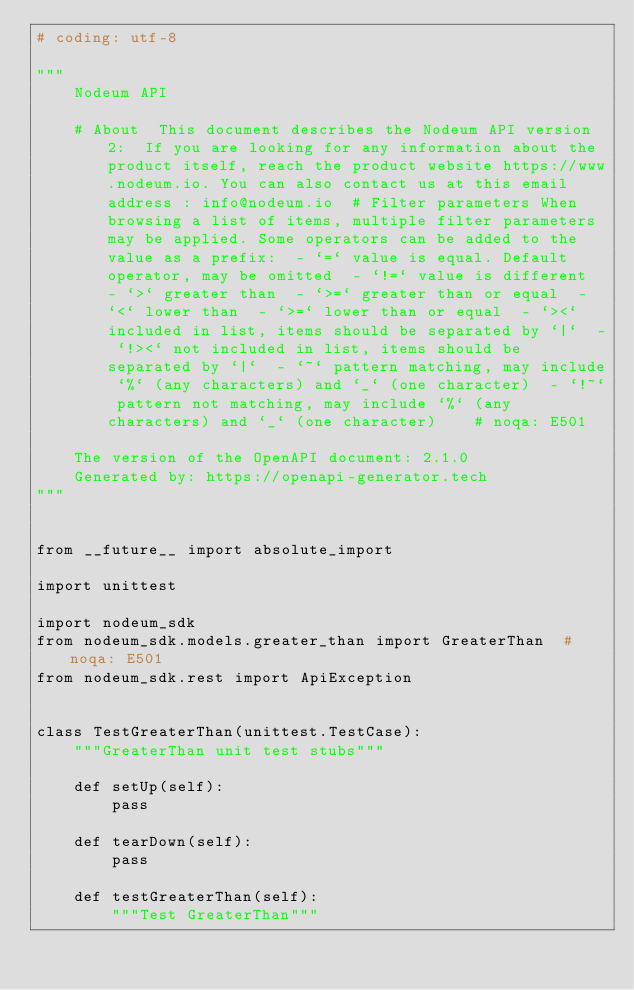Convert code to text. <code><loc_0><loc_0><loc_500><loc_500><_Python_># coding: utf-8

"""
    Nodeum API

    # About  This document describes the Nodeum API version 2:  If you are looking for any information about the product itself, reach the product website https://www.nodeum.io. You can also contact us at this email address : info@nodeum.io  # Filter parameters When browsing a list of items, multiple filter parameters may be applied. Some operators can be added to the value as a prefix:  - `=` value is equal. Default operator, may be omitted  - `!=` value is different  - `>` greater than  - `>=` greater than or equal  - `<` lower than  - `>=` lower than or equal  - `><` included in list, items should be separated by `|`  - `!><` not included in list, items should be separated by `|`  - `~` pattern matching, may include `%` (any characters) and `_` (one character)  - `!~` pattern not matching, may include `%` (any characters) and `_` (one character)    # noqa: E501

    The version of the OpenAPI document: 2.1.0
    Generated by: https://openapi-generator.tech
"""


from __future__ import absolute_import

import unittest

import nodeum_sdk
from nodeum_sdk.models.greater_than import GreaterThan  # noqa: E501
from nodeum_sdk.rest import ApiException


class TestGreaterThan(unittest.TestCase):
    """GreaterThan unit test stubs"""

    def setUp(self):
        pass

    def tearDown(self):
        pass

    def testGreaterThan(self):
        """Test GreaterThan"""</code> 